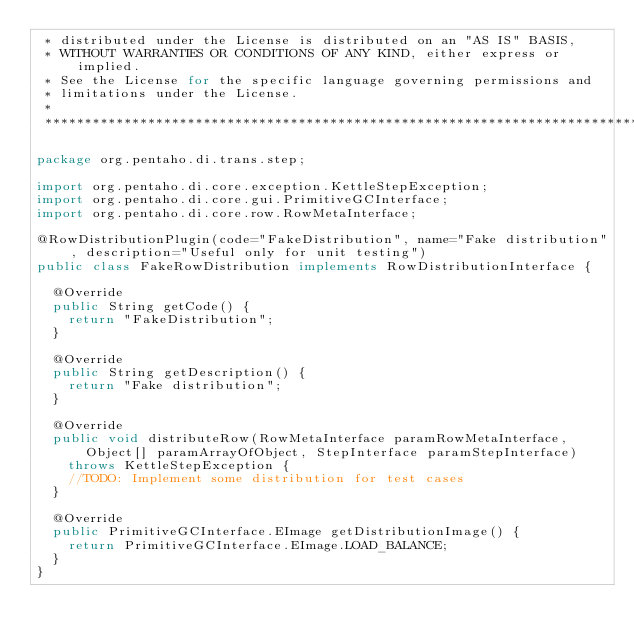Convert code to text. <code><loc_0><loc_0><loc_500><loc_500><_Java_> * distributed under the License is distributed on an "AS IS" BASIS,
 * WITHOUT WARRANTIES OR CONDITIONS OF ANY KIND, either express or implied.
 * See the License for the specific language governing permissions and
 * limitations under the License.
 *
 ******************************************************************************/

package org.pentaho.di.trans.step;

import org.pentaho.di.core.exception.KettleStepException;
import org.pentaho.di.core.gui.PrimitiveGCInterface;
import org.pentaho.di.core.row.RowMetaInterface;

@RowDistributionPlugin(code="FakeDistribution", name="Fake distribution", description="Useful only for unit testing")
public class FakeRowDistribution implements RowDistributionInterface {

  @Override
  public String getCode() {
    return "FakeDistribution";
  }

  @Override
  public String getDescription() {
    return "Fake distribution";
  }

  @Override
  public void distributeRow(RowMetaInterface paramRowMetaInterface, Object[] paramArrayOfObject, StepInterface paramStepInterface)
    throws KettleStepException {
    //TODO: Implement some distribution for test cases
  }

  @Override
  public PrimitiveGCInterface.EImage getDistributionImage() {
    return PrimitiveGCInterface.EImage.LOAD_BALANCE;
  }
}
</code> 